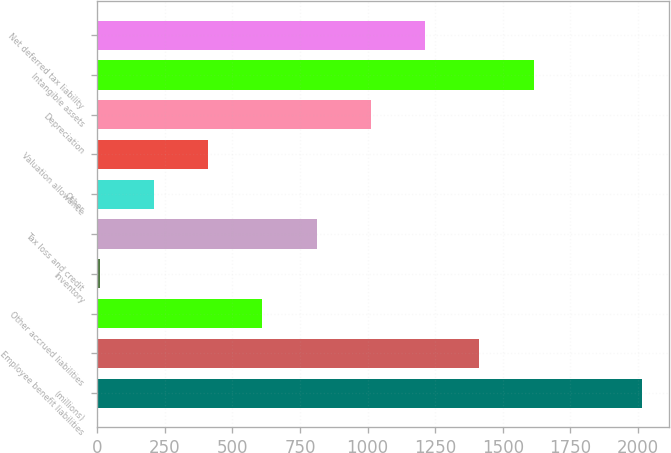Convert chart to OTSL. <chart><loc_0><loc_0><loc_500><loc_500><bar_chart><fcel>(millions)<fcel>Employee benefit liabilities<fcel>Other accrued liabilities<fcel>Inventory<fcel>Tax loss and credit<fcel>Other<fcel>Valuation allowance<fcel>Depreciation<fcel>Intangible assets<fcel>Net deferred tax liability<nl><fcel>2015<fcel>1413.32<fcel>611.08<fcel>9.4<fcel>811.64<fcel>209.96<fcel>410.52<fcel>1012.2<fcel>1613.88<fcel>1212.76<nl></chart> 